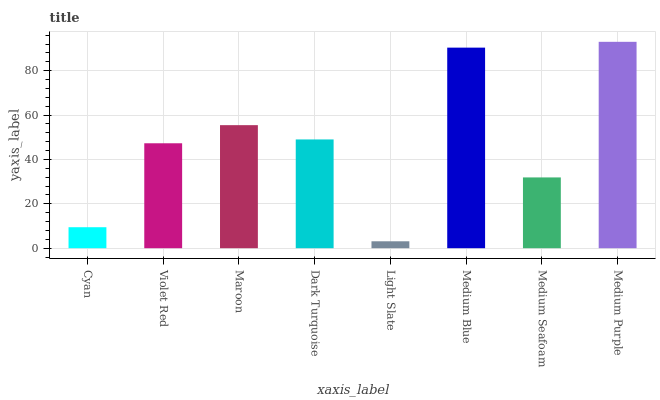Is Light Slate the minimum?
Answer yes or no. Yes. Is Medium Purple the maximum?
Answer yes or no. Yes. Is Violet Red the minimum?
Answer yes or no. No. Is Violet Red the maximum?
Answer yes or no. No. Is Violet Red greater than Cyan?
Answer yes or no. Yes. Is Cyan less than Violet Red?
Answer yes or no. Yes. Is Cyan greater than Violet Red?
Answer yes or no. No. Is Violet Red less than Cyan?
Answer yes or no. No. Is Dark Turquoise the high median?
Answer yes or no. Yes. Is Violet Red the low median?
Answer yes or no. Yes. Is Maroon the high median?
Answer yes or no. No. Is Cyan the low median?
Answer yes or no. No. 